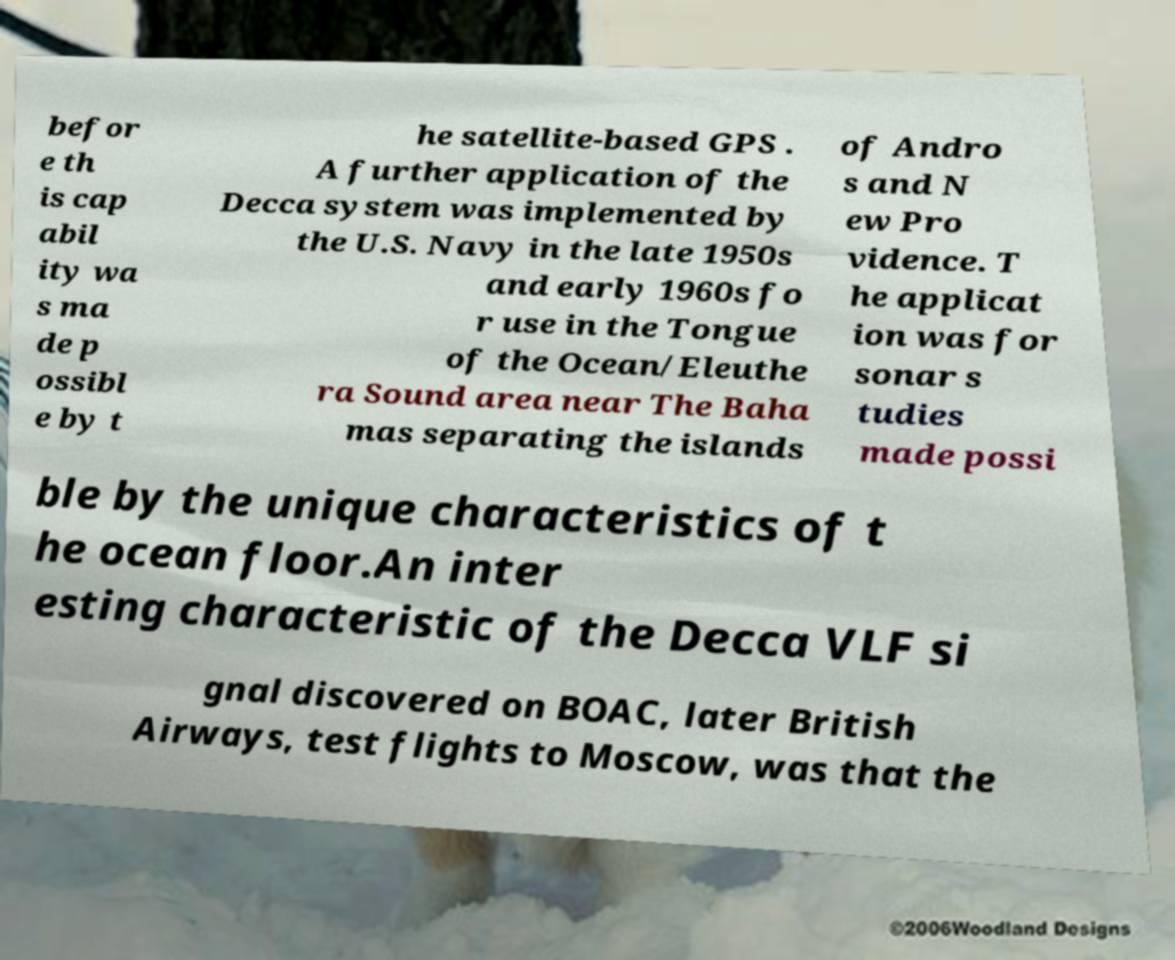Can you read and provide the text displayed in the image?This photo seems to have some interesting text. Can you extract and type it out for me? befor e th is cap abil ity wa s ma de p ossibl e by t he satellite-based GPS . A further application of the Decca system was implemented by the U.S. Navy in the late 1950s and early 1960s fo r use in the Tongue of the Ocean/Eleuthe ra Sound area near The Baha mas separating the islands of Andro s and N ew Pro vidence. T he applicat ion was for sonar s tudies made possi ble by the unique characteristics of t he ocean floor.An inter esting characteristic of the Decca VLF si gnal discovered on BOAC, later British Airways, test flights to Moscow, was that the 